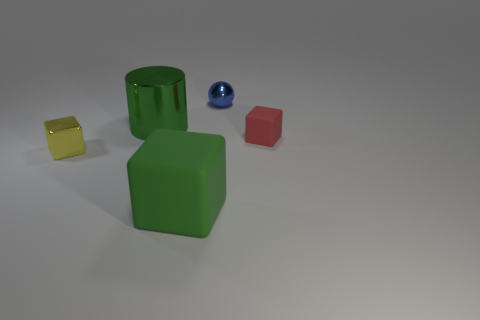There is a rubber thing that is the same color as the big metal cylinder; what is its shape?
Give a very brief answer. Cube. The big green rubber thing on the right side of the small yellow object has what shape?
Ensure brevity in your answer.  Cube. Do the large thing that is left of the green matte block and the blue thing have the same shape?
Your response must be concise. No. What number of things are tiny cubes that are to the left of the small red thing or red spheres?
Make the answer very short. 1. What color is the other rubber object that is the same shape as the big green rubber object?
Your response must be concise. Red. Is there any other thing that is the same color as the metallic ball?
Your answer should be compact. No. How big is the green object behind the green cube?
Ensure brevity in your answer.  Large. Do the cylinder and the small shiny thing that is in front of the small metallic sphere have the same color?
Your answer should be compact. No. What number of other objects are there of the same material as the big green cube?
Your answer should be compact. 1. Are there more blue metallic objects than matte cubes?
Your answer should be very brief. No. 